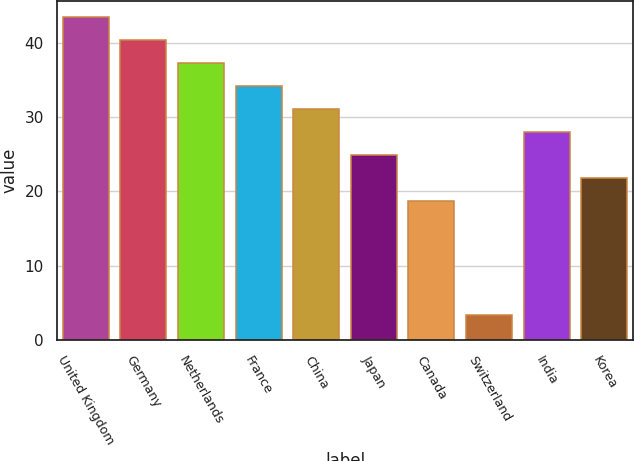Convert chart to OTSL. <chart><loc_0><loc_0><loc_500><loc_500><bar_chart><fcel>United Kingdom<fcel>Germany<fcel>Netherlands<fcel>France<fcel>China<fcel>Japan<fcel>Canada<fcel>Switzerland<fcel>India<fcel>Korea<nl><fcel>43.42<fcel>40.34<fcel>37.26<fcel>34.18<fcel>31.1<fcel>24.94<fcel>18.78<fcel>3.38<fcel>28.02<fcel>21.86<nl></chart> 